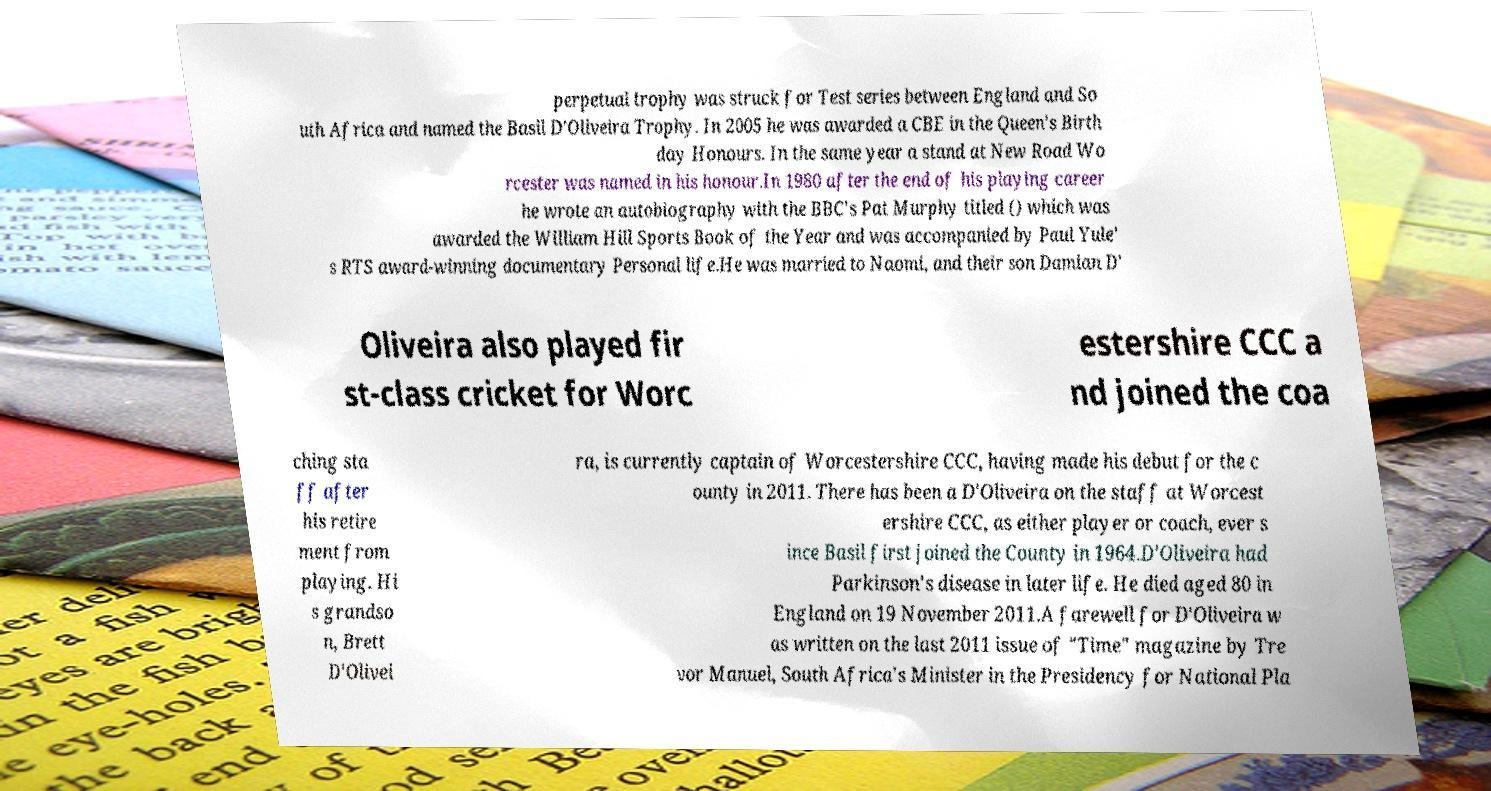What messages or text are displayed in this image? I need them in a readable, typed format. perpetual trophy was struck for Test series between England and So uth Africa and named the Basil D'Oliveira Trophy. In 2005 he was awarded a CBE in the Queen's Birth day Honours. In the same year a stand at New Road Wo rcester was named in his honour.In 1980 after the end of his playing career he wrote an autobiography with the BBC's Pat Murphy titled () which was awarded the William Hill Sports Book of the Year and was accompanied by Paul Yule' s RTS award-winning documentary Personal life.He was married to Naomi, and their son Damian D' Oliveira also played fir st-class cricket for Worc estershire CCC a nd joined the coa ching sta ff after his retire ment from playing. Hi s grandso n, Brett D'Olivei ra, is currently captain of Worcestershire CCC, having made his debut for the c ounty in 2011. There has been a D'Oliveira on the staff at Worcest ershire CCC, as either player or coach, ever s ince Basil first joined the County in 1964.D'Oliveira had Parkinson's disease in later life. He died aged 80 in England on 19 November 2011.A farewell for D'Oliveira w as written on the last 2011 issue of "Time" magazine by Tre vor Manuel, South Africa's Minister in the Presidency for National Pla 